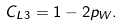<formula> <loc_0><loc_0><loc_500><loc_500>C _ { L 3 } = 1 - 2 p _ { W } .</formula> 